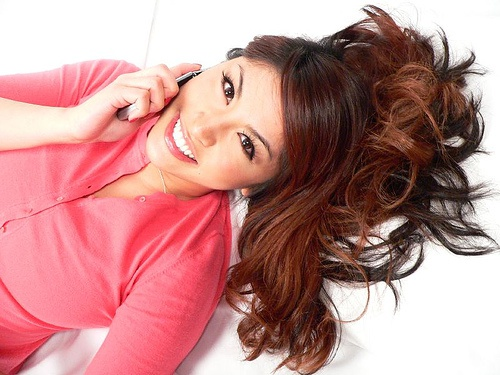Describe the objects in this image and their specific colors. I can see people in white, lightpink, maroon, black, and salmon tones and cell phone in white, brown, black, darkgray, and lightgray tones in this image. 